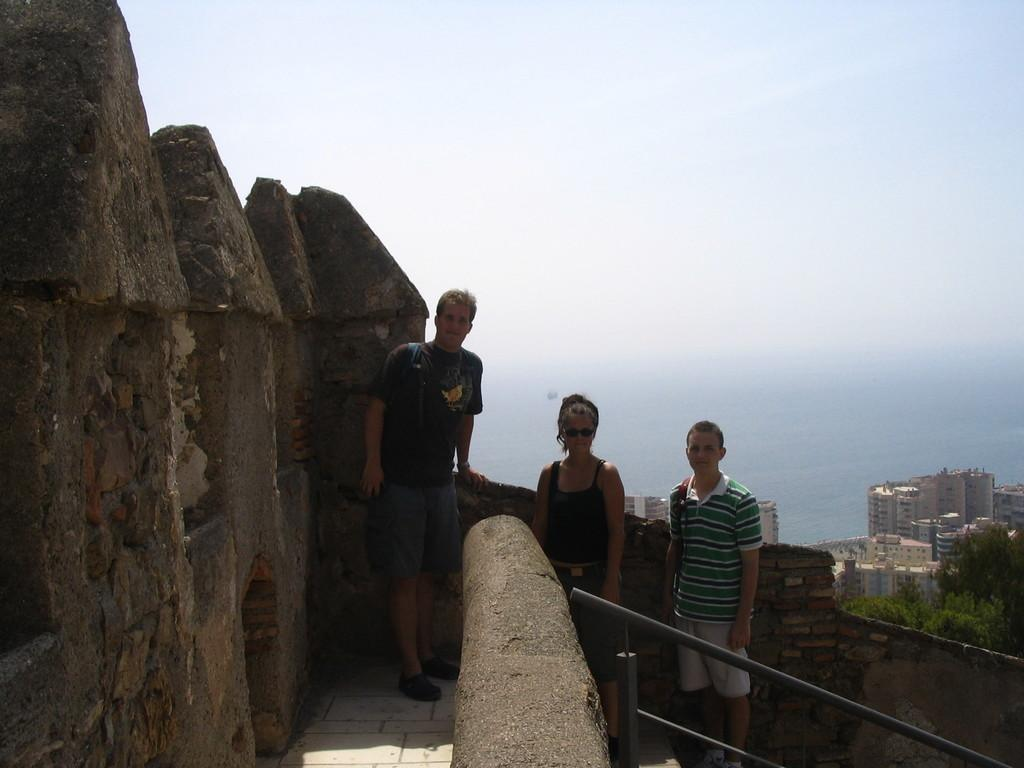How many people are in the image? There are three people in the image: two men and a woman. What are the people in the image doing? The people are standing. What can be seen in the background of the image? There are buildings, trees, water, and the sky visible in the background of the image. What type of coat is the woman wearing in the image? There is no coat visible in the image; the woman is not wearing one. How many mice can be seen running around in the image? There are no mice present in the image. 